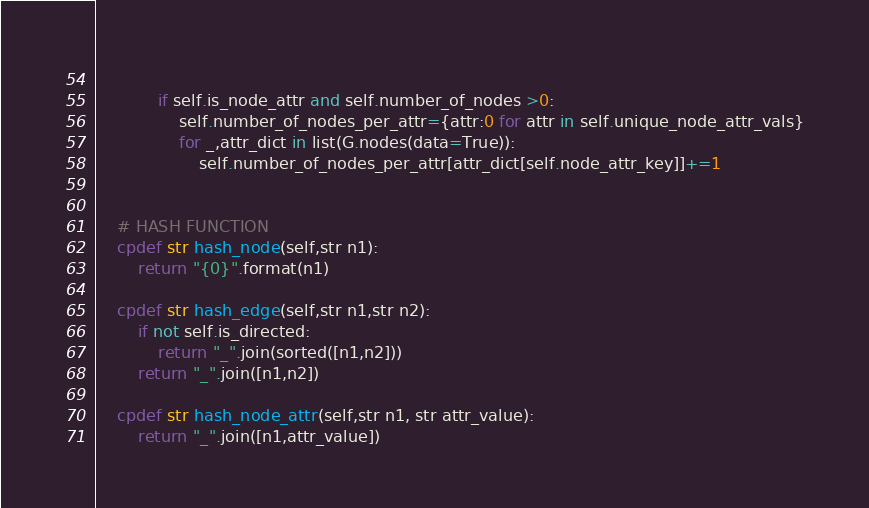Convert code to text. <code><loc_0><loc_0><loc_500><loc_500><_Cython_>            
            if self.is_node_attr and self.number_of_nodes >0:
                self.number_of_nodes_per_attr={attr:0 for attr in self.unique_node_attr_vals}
                for _,attr_dict in list(G.nodes(data=True)):
                    self.number_of_nodes_per_attr[attr_dict[self.node_attr_key]]+=1

    
    # HASH FUNCTION
    cpdef str hash_node(self,str n1):
        return "{0}".format(n1)

    cpdef str hash_edge(self,str n1,str n2):
        if not self.is_directed:
            return "_".join(sorted([n1,n2]))
        return "_".join([n1,n2])

    cpdef str hash_node_attr(self,str n1, str attr_value):
        return "_".join([n1,attr_value])
</code> 